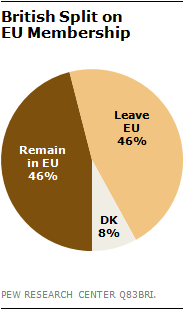Highlight a few significant elements in this photo. The ratio of the two largest segments in the sequence 1... is 1:1. The pie chart has only three segments. Yes, there are three segments in the pie chart. 